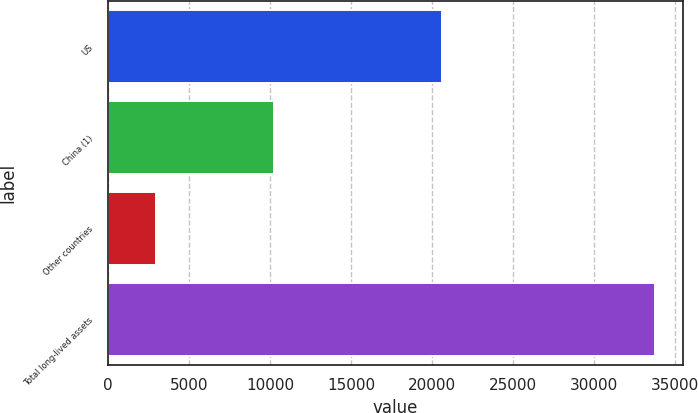<chart> <loc_0><loc_0><loc_500><loc_500><bar_chart><fcel>US<fcel>China (1)<fcel>Other countries<fcel>Total long-lived assets<nl><fcel>20637<fcel>10211<fcel>2935<fcel>33783<nl></chart> 